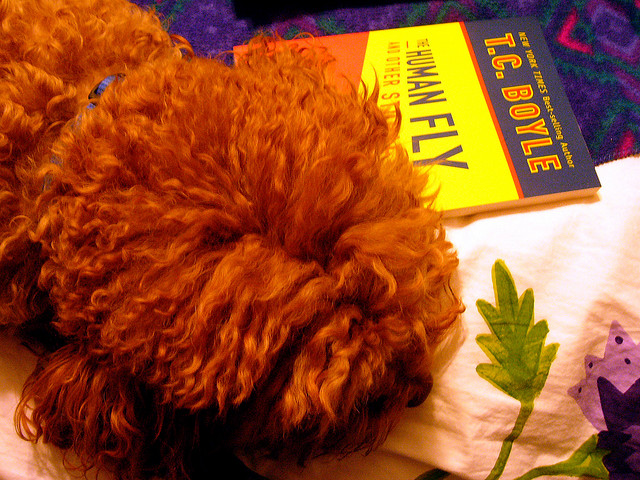Please transcribe the text information in this image. T.C. BOYLE NEW YORK TIMES S OTHER AND HUMAN FLY THE Author SELLING Best 